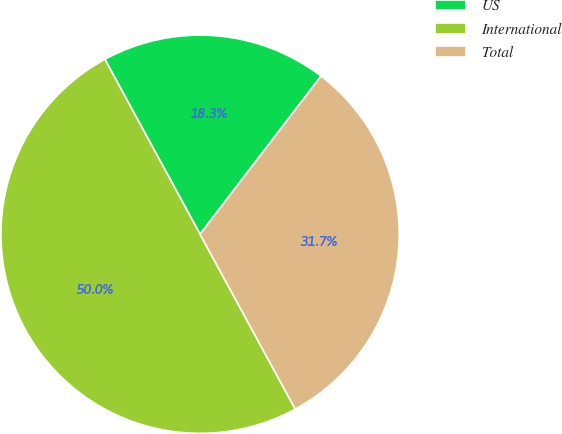Convert chart to OTSL. <chart><loc_0><loc_0><loc_500><loc_500><pie_chart><fcel>US<fcel>International<fcel>Total<nl><fcel>18.33%<fcel>50.0%<fcel>31.67%<nl></chart> 